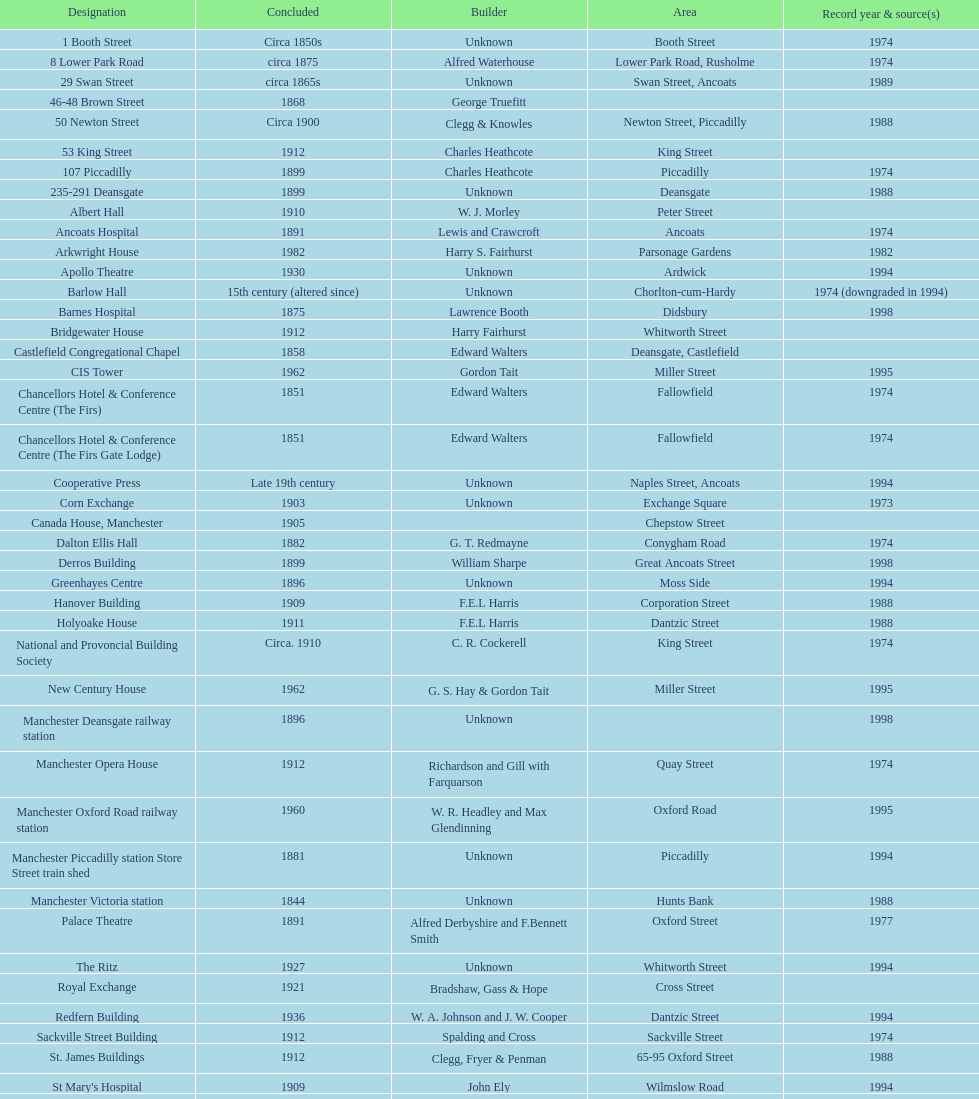Which two buildings were listed before 1974? The Old Wellington Inn, Smithfield Market Hall. Parse the table in full. {'header': ['Designation', 'Concluded', 'Builder', 'Area', 'Record year & source(s)'], 'rows': [['1 Booth Street', 'Circa 1850s', 'Unknown', 'Booth Street', '1974'], ['8 Lower Park Road', 'circa 1875', 'Alfred Waterhouse', 'Lower Park Road, Rusholme', '1974'], ['29 Swan Street', 'circa 1865s', 'Unknown', 'Swan Street, Ancoats', '1989'], ['46-48 Brown Street', '1868', 'George Truefitt', '', ''], ['50 Newton Street', 'Circa 1900', 'Clegg & Knowles', 'Newton Street, Piccadilly', '1988'], ['53 King Street', '1912', 'Charles Heathcote', 'King Street', ''], ['107 Piccadilly', '1899', 'Charles Heathcote', 'Piccadilly', '1974'], ['235-291 Deansgate', '1899', 'Unknown', 'Deansgate', '1988'], ['Albert Hall', '1910', 'W. J. Morley', 'Peter Street', ''], ['Ancoats Hospital', '1891', 'Lewis and Crawcroft', 'Ancoats', '1974'], ['Arkwright House', '1982', 'Harry S. Fairhurst', 'Parsonage Gardens', '1982'], ['Apollo Theatre', '1930', 'Unknown', 'Ardwick', '1994'], ['Barlow Hall', '15th century (altered since)', 'Unknown', 'Chorlton-cum-Hardy', '1974 (downgraded in 1994)'], ['Barnes Hospital', '1875', 'Lawrence Booth', 'Didsbury', '1998'], ['Bridgewater House', '1912', 'Harry Fairhurst', 'Whitworth Street', ''], ['Castlefield Congregational Chapel', '1858', 'Edward Walters', 'Deansgate, Castlefield', ''], ['CIS Tower', '1962', 'Gordon Tait', 'Miller Street', '1995'], ['Chancellors Hotel & Conference Centre (The Firs)', '1851', 'Edward Walters', 'Fallowfield', '1974'], ['Chancellors Hotel & Conference Centre (The Firs Gate Lodge)', '1851', 'Edward Walters', 'Fallowfield', '1974'], ['Cooperative Press', 'Late 19th century', 'Unknown', 'Naples Street, Ancoats', '1994'], ['Corn Exchange', '1903', 'Unknown', 'Exchange Square', '1973'], ['Canada House, Manchester', '1905', '', 'Chepstow Street', ''], ['Dalton Ellis Hall', '1882', 'G. T. Redmayne', 'Conygham Road', '1974'], ['Derros Building', '1899', 'William Sharpe', 'Great Ancoats Street', '1998'], ['Greenhayes Centre', '1896', 'Unknown', 'Moss Side', '1994'], ['Hanover Building', '1909', 'F.E.L Harris', 'Corporation Street', '1988'], ['Holyoake House', '1911', 'F.E.L Harris', 'Dantzic Street', '1988'], ['National and Provoncial Building Society', 'Circa. 1910', 'C. R. Cockerell', 'King Street', '1974'], ['New Century House', '1962', 'G. S. Hay & Gordon Tait', 'Miller Street', '1995'], ['Manchester Deansgate railway station', '1896', 'Unknown', '', '1998'], ['Manchester Opera House', '1912', 'Richardson and Gill with Farquarson', 'Quay Street', '1974'], ['Manchester Oxford Road railway station', '1960', 'W. R. Headley and Max Glendinning', 'Oxford Road', '1995'], ['Manchester Piccadilly station Store Street train shed', '1881', 'Unknown', 'Piccadilly', '1994'], ['Manchester Victoria station', '1844', 'Unknown', 'Hunts Bank', '1988'], ['Palace Theatre', '1891', 'Alfred Derbyshire and F.Bennett Smith', 'Oxford Street', '1977'], ['The Ritz', '1927', 'Unknown', 'Whitworth Street', '1994'], ['Royal Exchange', '1921', 'Bradshaw, Gass & Hope', 'Cross Street', ''], ['Redfern Building', '1936', 'W. A. Johnson and J. W. Cooper', 'Dantzic Street', '1994'], ['Sackville Street Building', '1912', 'Spalding and Cross', 'Sackville Street', '1974'], ['St. James Buildings', '1912', 'Clegg, Fryer & Penman', '65-95 Oxford Street', '1988'], ["St Mary's Hospital", '1909', 'John Ely', 'Wilmslow Road', '1994'], ['Samuel Alexander Building', '1919', 'Percy Scott Worthington', 'Oxford Road', '2010'], ['Ship Canal House', '1927', 'Harry S. Fairhurst', 'King Street', '1982'], ['Smithfield Market Hall', '1857', 'Unknown', 'Swan Street, Ancoats', '1973'], ['Strangeways Gaol Gatehouse', '1868', 'Alfred Waterhouse', 'Sherborne Street', '1974'], ['Strangeways Prison ventilation and watch tower', '1868', 'Alfred Waterhouse', 'Sherborne Street', '1974'], ['Theatre Royal', '1845', 'Irwin and Chester', 'Peter Street', '1974'], ['Toast Rack', '1960', 'L. C. Howitt', 'Fallowfield', '1999'], ['The Old Wellington Inn', 'Mid-16th century', 'Unknown', 'Shambles Square', '1952'], ['Whitworth Park Mansions', 'Circa 1840s', 'Unknown', 'Whitworth Park', '1974']]} 